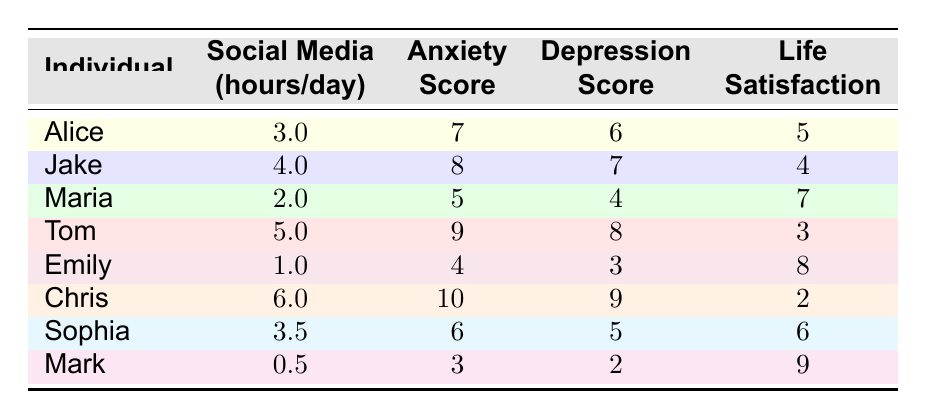What is the social media usage of Tom? Tom's social media usage is given in the table as 5.0 hours per day.
Answer: 5.0 hours/day Who has the highest anxiety score? Chris has the highest anxiety score of 10, as seen in the table under the anxiety score column.
Answer: Chris What is the average life satisfaction score of the individuals listed? The life satisfaction scores are 5, 4, 7, 3, 8, 2, 6, and 9. The sum of these scores is 5 + 4 + 7 + 3 + 8 + 2 + 6 + 9 = 44. There are 8 individuals, so the average is 44/8 = 5.5.
Answer: 5.5 Is Jake's anxiety score higher than Maria's? Jake's anxiety score is 8, while Maria's is 5. Since 8 is greater than 5, the statement is true.
Answer: Yes What is the difference in social media usage between Chris and Mark? Chris uses social media for 6.0 hours per day, and Mark uses it for 0.5 hours per day. The difference is 6.0 - 0.5 = 5.5 hours.
Answer: 5.5 hours How many individuals have a life satisfaction score of 6 or higher? The individuals with life satisfaction scores of 6 or higher are Maria (7), Emily (8), and Mark (9). Therefore, there are 5 individuals: Maria, Emily, Sophia, and Mark, totaling 5.
Answer: 5 What is the relationship between social media hours and life satisfaction based on the data? By analyzing the table, a common observation is that as social media usage increases, life satisfaction generally decreases. For instance, Chris (6 hours, 2 satisfaction) versus Emily (1 hour, 8 satisfaction) demonstrates this trend, suggesting a negative correlation.
Answer: Negative correlation Is there any individual who uses less than 2 hours of social media per day? Mark uses only 0.5 hours of social media, which is less than 2 hours. Therefore, the statement is true.
Answer: Yes 